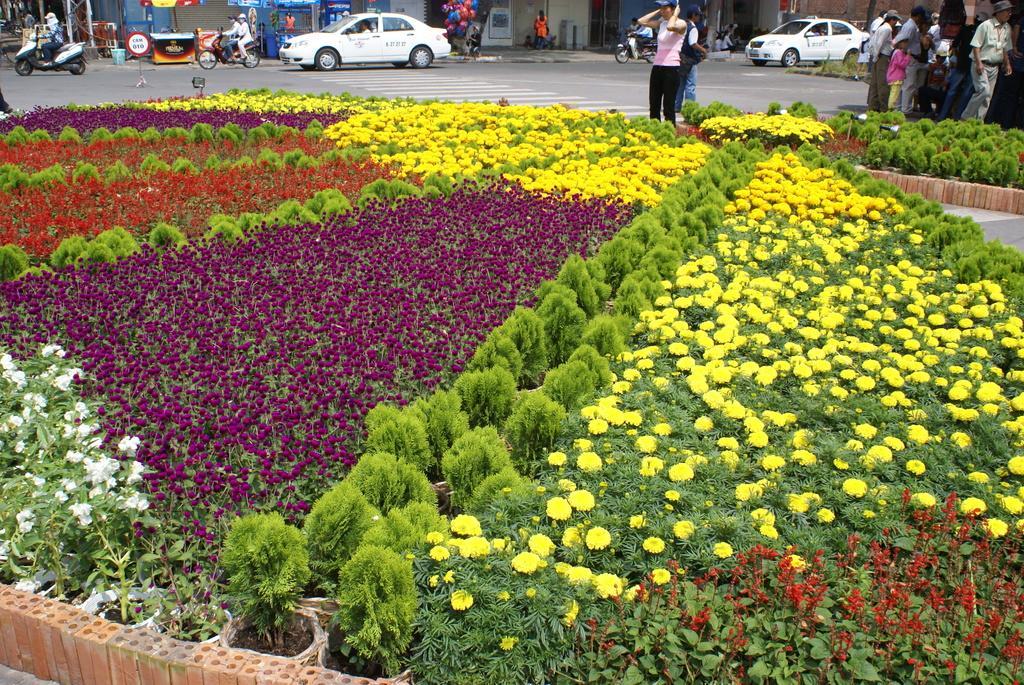In one or two sentences, can you explain what this image depicts? In this picture, we can see the ground with grass, plants, flowers, and we can see some objects on the bottom left side of the picture, we can see lights, a few vehicles, stores, posters, poles, balloons, and a few people. 